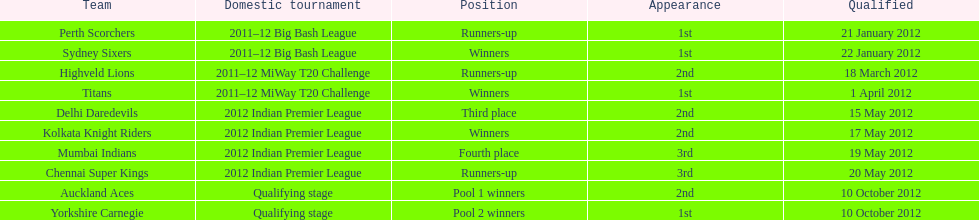Can you parse all the data within this table? {'header': ['Team', 'Domestic tournament', 'Position', 'Appearance', 'Qualified'], 'rows': [['Perth Scorchers', '2011–12 Big Bash League', 'Runners-up', '1st', '21 January 2012'], ['Sydney Sixers', '2011–12 Big Bash League', 'Winners', '1st', '22 January 2012'], ['Highveld Lions', '2011–12 MiWay T20 Challenge', 'Runners-up', '2nd', '18 March 2012'], ['Titans', '2011–12 MiWay T20 Challenge', 'Winners', '1st', '1 April 2012'], ['Delhi Daredevils', '2012 Indian Premier League', 'Third place', '2nd', '15 May 2012'], ['Kolkata Knight Riders', '2012 Indian Premier League', 'Winners', '2nd', '17 May 2012'], ['Mumbai Indians', '2012 Indian Premier League', 'Fourth place', '3rd', '19 May 2012'], ['Chennai Super Kings', '2012 Indian Premier League', 'Runners-up', '3rd', '20 May 2012'], ['Auckland Aces', 'Qualifying stage', 'Pool 1 winners', '2nd', '10 October 2012'], ['Yorkshire Carnegie', 'Qualifying stage', 'Pool 2 winners', '1st', '10 October 2012']]} Which team came in after the titans in the miway t20 challenge? Highveld Lions. 